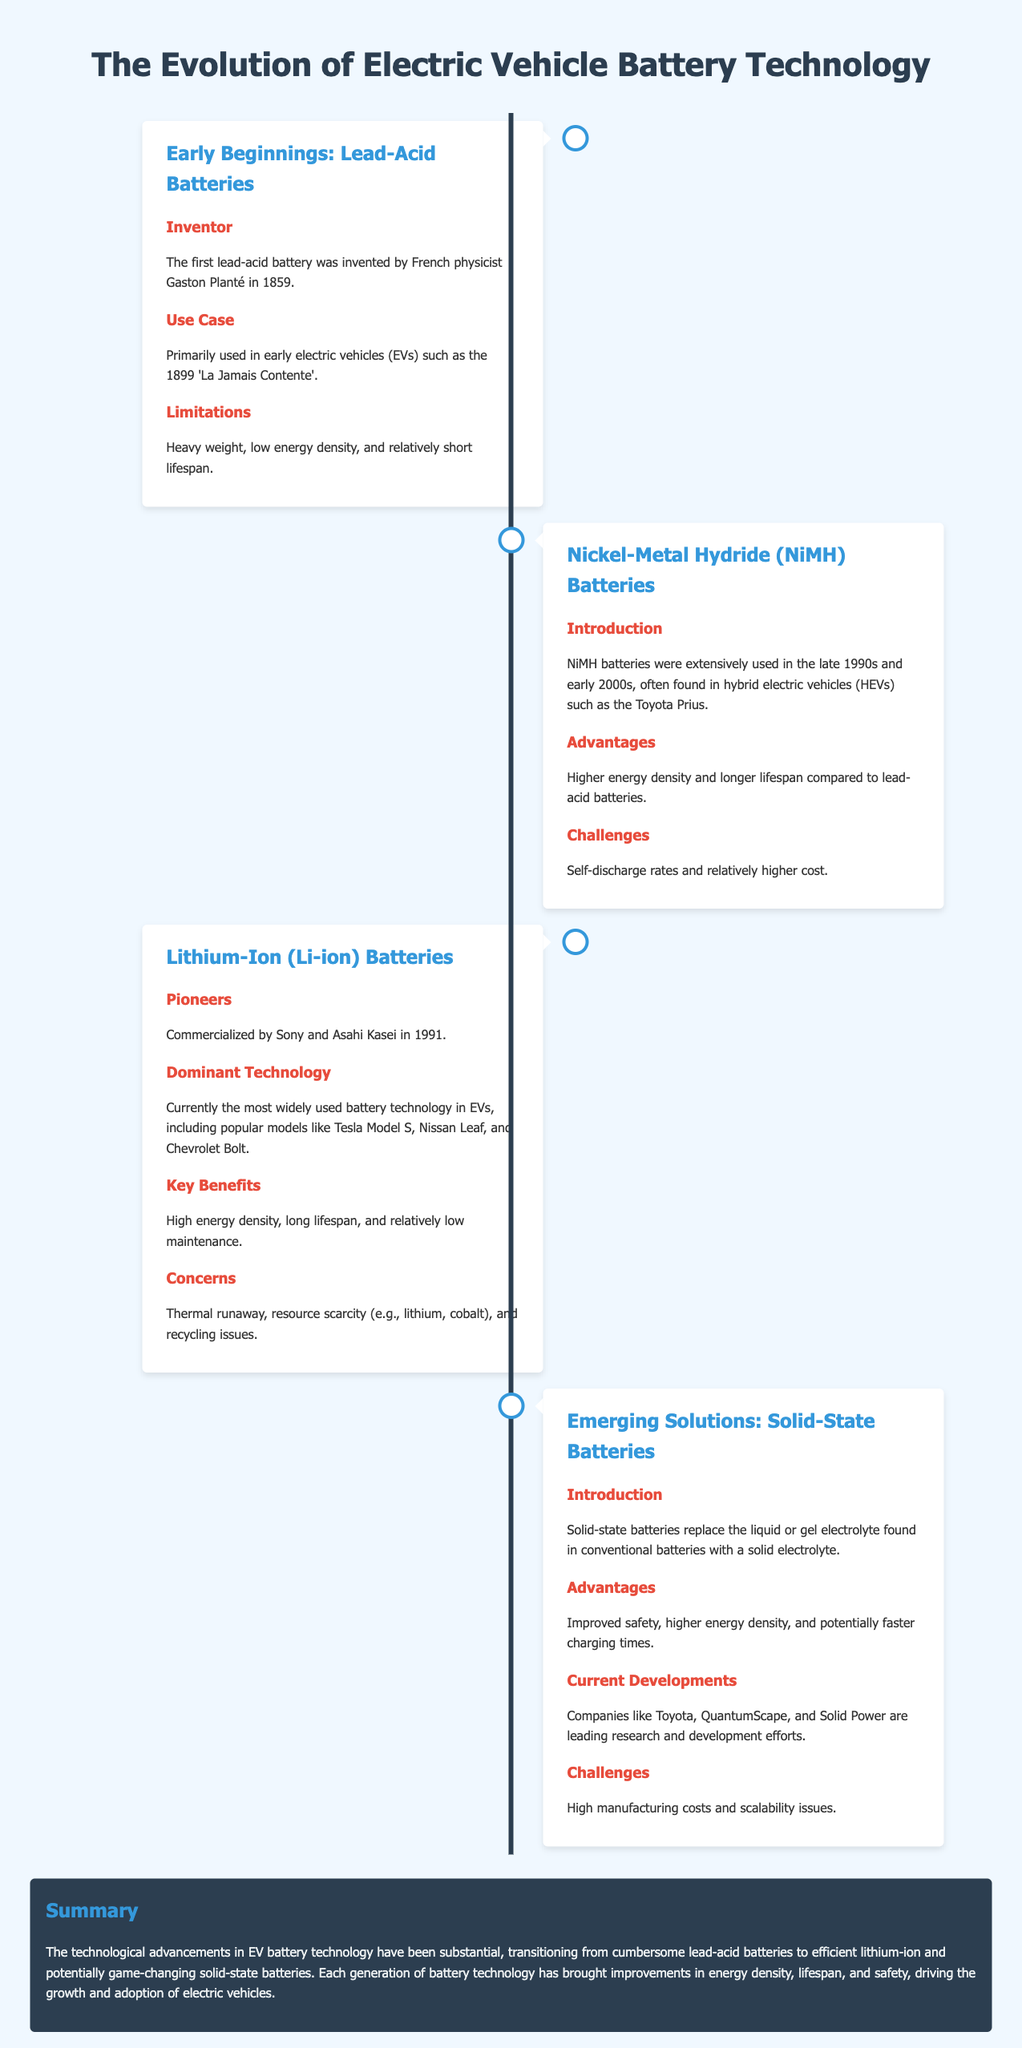What battery technology was invented by Gaston Planté? The document states that the first lead-acid battery was invented by French physicist Gaston Planté in 1859.
Answer: Lead-Acid Batteries Which vehicle prominently used NiMH batteries? According to the document, NiMH batteries were often found in hybrid electric vehicles, particularly the Toyota Prius.
Answer: Toyota Prius When were lithium-ion batteries commercialized? The document mentions that lithium-ion batteries were commercialized by Sony and Asahi Kasei in 1991.
Answer: 1991 What is a major concern associated with lithium-ion batteries? The document highlights thermal runaway, resource scarcity, and recycling issues as concerns related to lithium-ion batteries.
Answer: Thermal runaway Which companies are leading developments in solid-state batteries? The document lists companies like Toyota, QuantumScape, and Solid Power as leaders in research and development for solid-state batteries.
Answer: Toyota, QuantumScape, Solid Power What are the key benefits of lithium-ion batteries? The document outlines high energy density, long lifespan, and relatively low maintenance as key benefits of lithium-ion batteries.
Answer: High energy density, long lifespan, low maintenance What is a significant advantage of solid-state batteries? The document indicates improved safety as a significant advantage of solid-state batteries.
Answer: Improved safety What was the primary limitation of lead-acid batteries? The document states that lead-acid batteries have heavy weight, low energy density, and relatively short lifespan as limitations.
Answer: Heavy weight, low energy density How do solid-state batteries differ from conventional batteries? According to the document, solid-state batteries replace the liquid or gel electrolyte found in conventional batteries with a solid electrolyte.
Answer: Solid electrolyte 